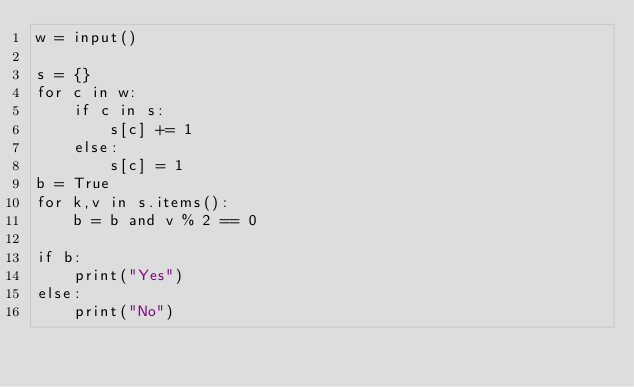Convert code to text. <code><loc_0><loc_0><loc_500><loc_500><_Python_>w = input()

s = {}
for c in w:
    if c in s:
        s[c] += 1
    else:
        s[c] = 1
b = True
for k,v in s.items():
    b = b and v % 2 == 0

if b:
    print("Yes")
else:
    print("No")
</code> 